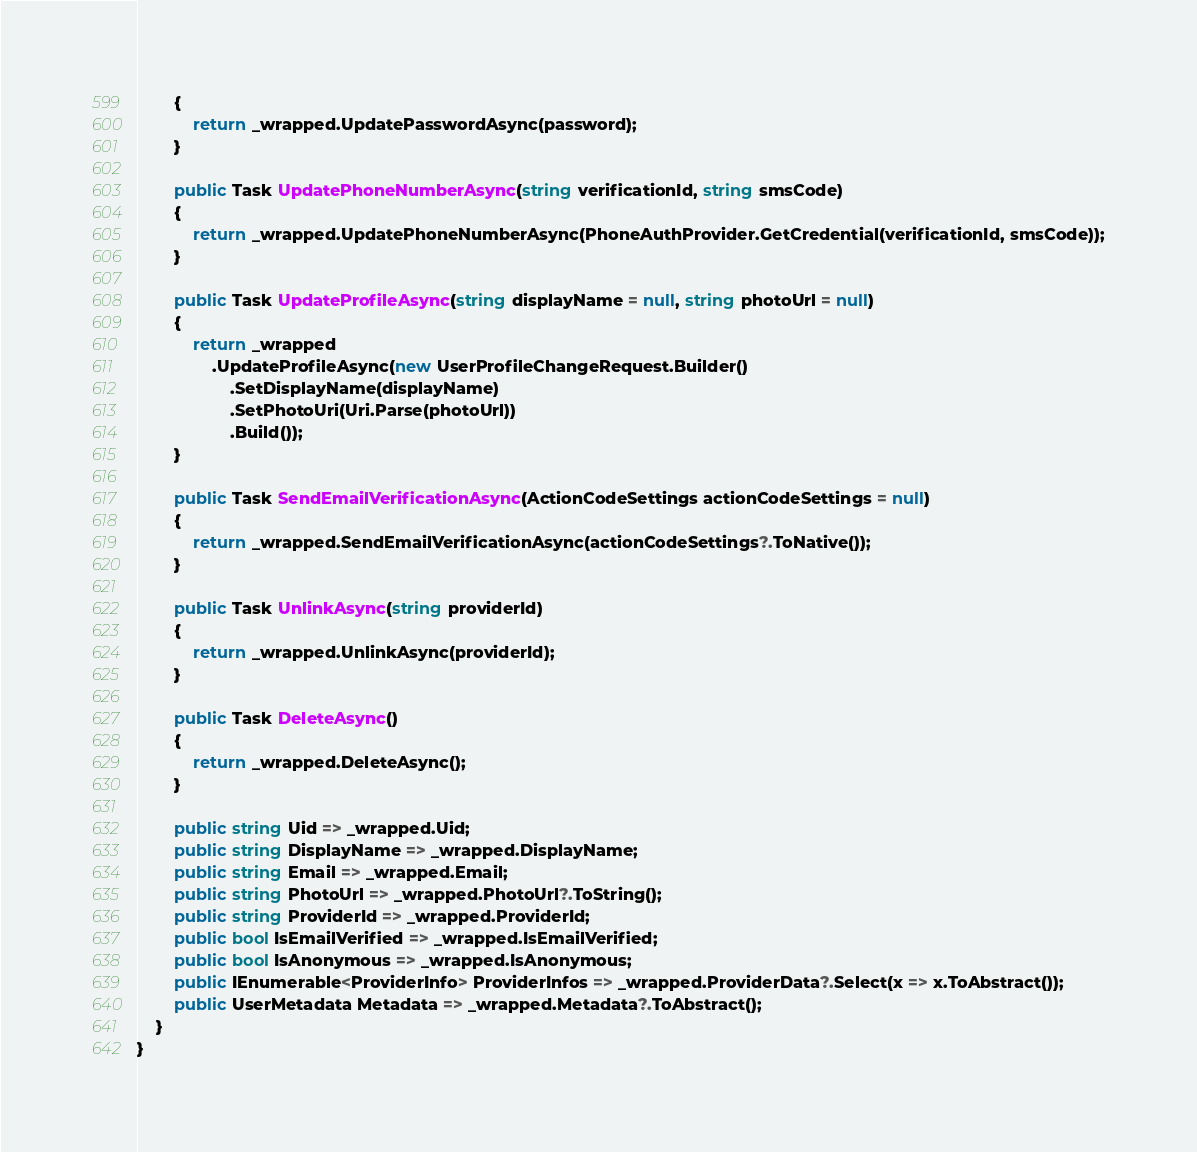Convert code to text. <code><loc_0><loc_0><loc_500><loc_500><_C#_>        {
            return _wrapped.UpdatePasswordAsync(password);
        }

        public Task UpdatePhoneNumberAsync(string verificationId, string smsCode)
        {
            return _wrapped.UpdatePhoneNumberAsync(PhoneAuthProvider.GetCredential(verificationId, smsCode));
        }

        public Task UpdateProfileAsync(string displayName = null, string photoUrl = null)
        {
            return _wrapped
                .UpdateProfileAsync(new UserProfileChangeRequest.Builder()
                    .SetDisplayName(displayName)
                    .SetPhotoUri(Uri.Parse(photoUrl))
                    .Build());
        }

        public Task SendEmailVerificationAsync(ActionCodeSettings actionCodeSettings = null)
        {
            return _wrapped.SendEmailVerificationAsync(actionCodeSettings?.ToNative());
        }

        public Task UnlinkAsync(string providerId)
        {
            return _wrapped.UnlinkAsync(providerId);
        }

        public Task DeleteAsync()
        {
            return _wrapped.DeleteAsync();
        }
        
        public string Uid => _wrapped.Uid;
        public string DisplayName => _wrapped.DisplayName;
        public string Email => _wrapped.Email;
        public string PhotoUrl => _wrapped.PhotoUrl?.ToString();
        public string ProviderId => _wrapped.ProviderId;
        public bool IsEmailVerified => _wrapped.IsEmailVerified;
        public bool IsAnonymous => _wrapped.IsAnonymous;
        public IEnumerable<ProviderInfo> ProviderInfos => _wrapped.ProviderData?.Select(x => x.ToAbstract());
        public UserMetadata Metadata => _wrapped.Metadata?.ToAbstract();
    }
}</code> 